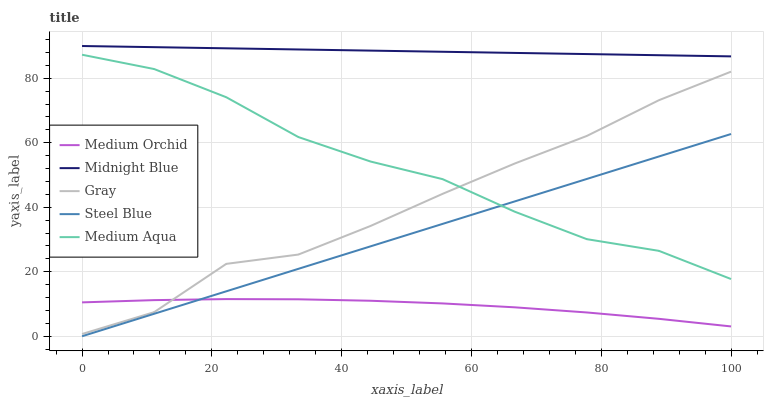Does Medium Orchid have the minimum area under the curve?
Answer yes or no. Yes. Does Midnight Blue have the maximum area under the curve?
Answer yes or no. Yes. Does Medium Aqua have the minimum area under the curve?
Answer yes or no. No. Does Medium Aqua have the maximum area under the curve?
Answer yes or no. No. Is Steel Blue the smoothest?
Answer yes or no. Yes. Is Gray the roughest?
Answer yes or no. Yes. Is Medium Orchid the smoothest?
Answer yes or no. No. Is Medium Orchid the roughest?
Answer yes or no. No. Does Medium Orchid have the lowest value?
Answer yes or no. No. Does Midnight Blue have the highest value?
Answer yes or no. Yes. Does Medium Aqua have the highest value?
Answer yes or no. No. Is Medium Aqua less than Midnight Blue?
Answer yes or no. Yes. Is Gray greater than Steel Blue?
Answer yes or no. Yes. Does Steel Blue intersect Medium Aqua?
Answer yes or no. Yes. Is Steel Blue less than Medium Aqua?
Answer yes or no. No. Is Steel Blue greater than Medium Aqua?
Answer yes or no. No. Does Medium Aqua intersect Midnight Blue?
Answer yes or no. No. 